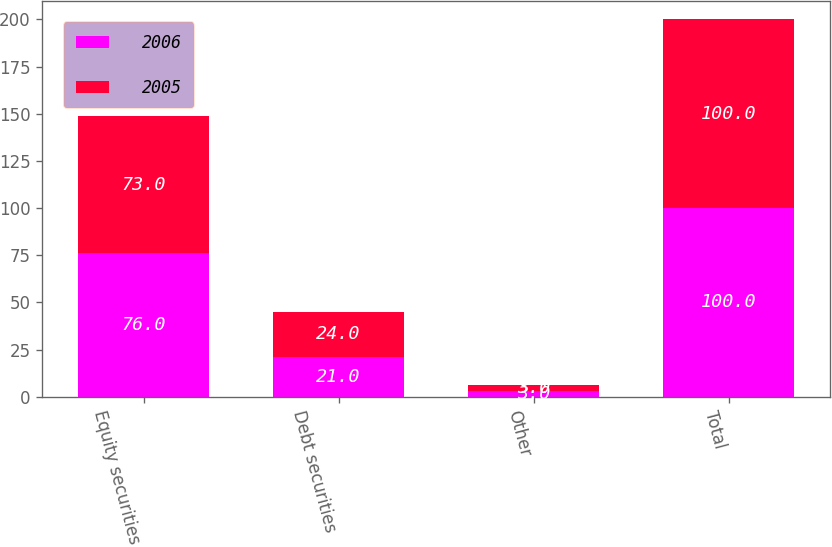Convert chart to OTSL. <chart><loc_0><loc_0><loc_500><loc_500><stacked_bar_chart><ecel><fcel>Equity securities<fcel>Debt securities<fcel>Other<fcel>Total<nl><fcel>2006<fcel>76<fcel>21<fcel>3<fcel>100<nl><fcel>2005<fcel>73<fcel>24<fcel>3<fcel>100<nl></chart> 